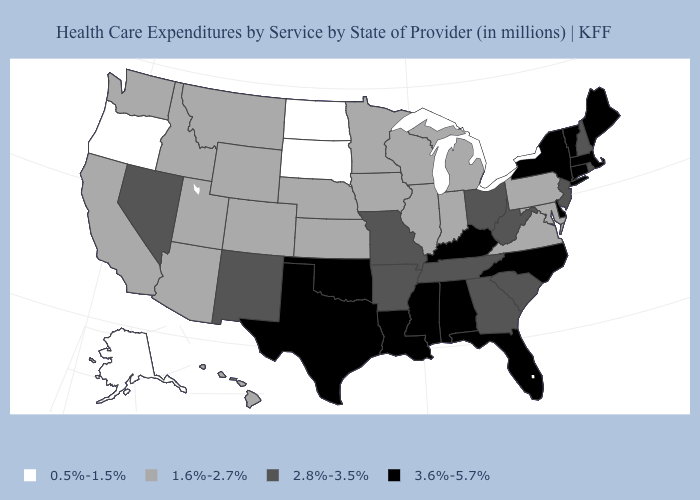What is the value of Idaho?
Be succinct. 1.6%-2.7%. Does the first symbol in the legend represent the smallest category?
Concise answer only. Yes. Name the states that have a value in the range 1.6%-2.7%?
Concise answer only. Arizona, California, Colorado, Hawaii, Idaho, Illinois, Indiana, Iowa, Kansas, Maryland, Michigan, Minnesota, Montana, Nebraska, Pennsylvania, Utah, Virginia, Washington, Wisconsin, Wyoming. Which states have the highest value in the USA?
Write a very short answer. Alabama, Connecticut, Delaware, Florida, Kentucky, Louisiana, Maine, Massachusetts, Mississippi, New York, North Carolina, Oklahoma, Texas, Vermont. What is the value of Maine?
Keep it brief. 3.6%-5.7%. How many symbols are there in the legend?
Give a very brief answer. 4. What is the value of Virginia?
Answer briefly. 1.6%-2.7%. Among the states that border Iowa , does South Dakota have the lowest value?
Answer briefly. Yes. Which states have the lowest value in the USA?
Keep it brief. Alaska, North Dakota, Oregon, South Dakota. What is the value of Massachusetts?
Give a very brief answer. 3.6%-5.7%. Does Oregon have a lower value than South Dakota?
Write a very short answer. No. Among the states that border North Dakota , does South Dakota have the highest value?
Be succinct. No. What is the value of Massachusetts?
Concise answer only. 3.6%-5.7%. What is the highest value in the USA?
Give a very brief answer. 3.6%-5.7%. Name the states that have a value in the range 0.5%-1.5%?
Write a very short answer. Alaska, North Dakota, Oregon, South Dakota. 